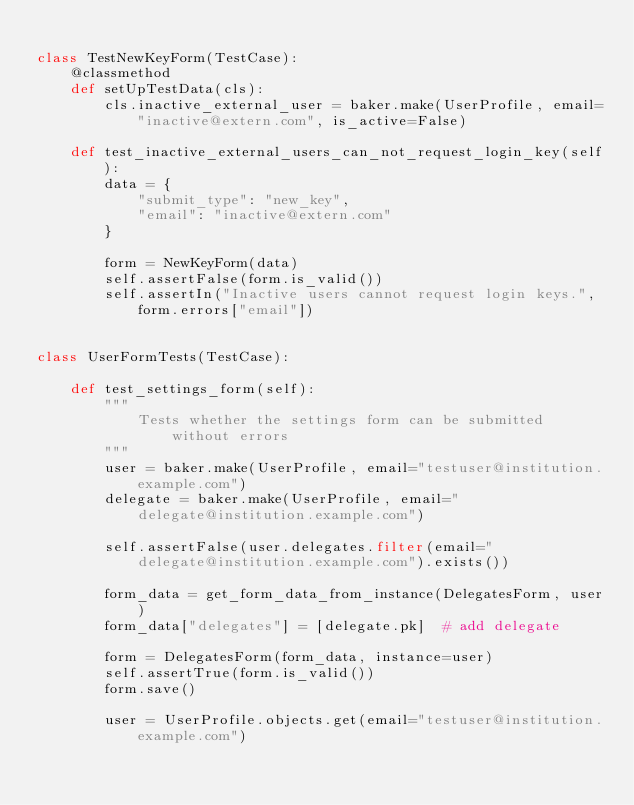Convert code to text. <code><loc_0><loc_0><loc_500><loc_500><_Python_>
class TestNewKeyForm(TestCase):
    @classmethod
    def setUpTestData(cls):
        cls.inactive_external_user = baker.make(UserProfile, email="inactive@extern.com", is_active=False)

    def test_inactive_external_users_can_not_request_login_key(self):
        data = {
            "submit_type": "new_key",
            "email": "inactive@extern.com"
        }

        form = NewKeyForm(data)
        self.assertFalse(form.is_valid())
        self.assertIn("Inactive users cannot request login keys.", form.errors["email"])


class UserFormTests(TestCase):

    def test_settings_form(self):
        """
            Tests whether the settings form can be submitted without errors
        """
        user = baker.make(UserProfile, email="testuser@institution.example.com")
        delegate = baker.make(UserProfile, email="delegate@institution.example.com")

        self.assertFalse(user.delegates.filter(email="delegate@institution.example.com").exists())

        form_data = get_form_data_from_instance(DelegatesForm, user)
        form_data["delegates"] = [delegate.pk]  # add delegate

        form = DelegatesForm(form_data, instance=user)
        self.assertTrue(form.is_valid())
        form.save()

        user = UserProfile.objects.get(email="testuser@institution.example.com")</code> 